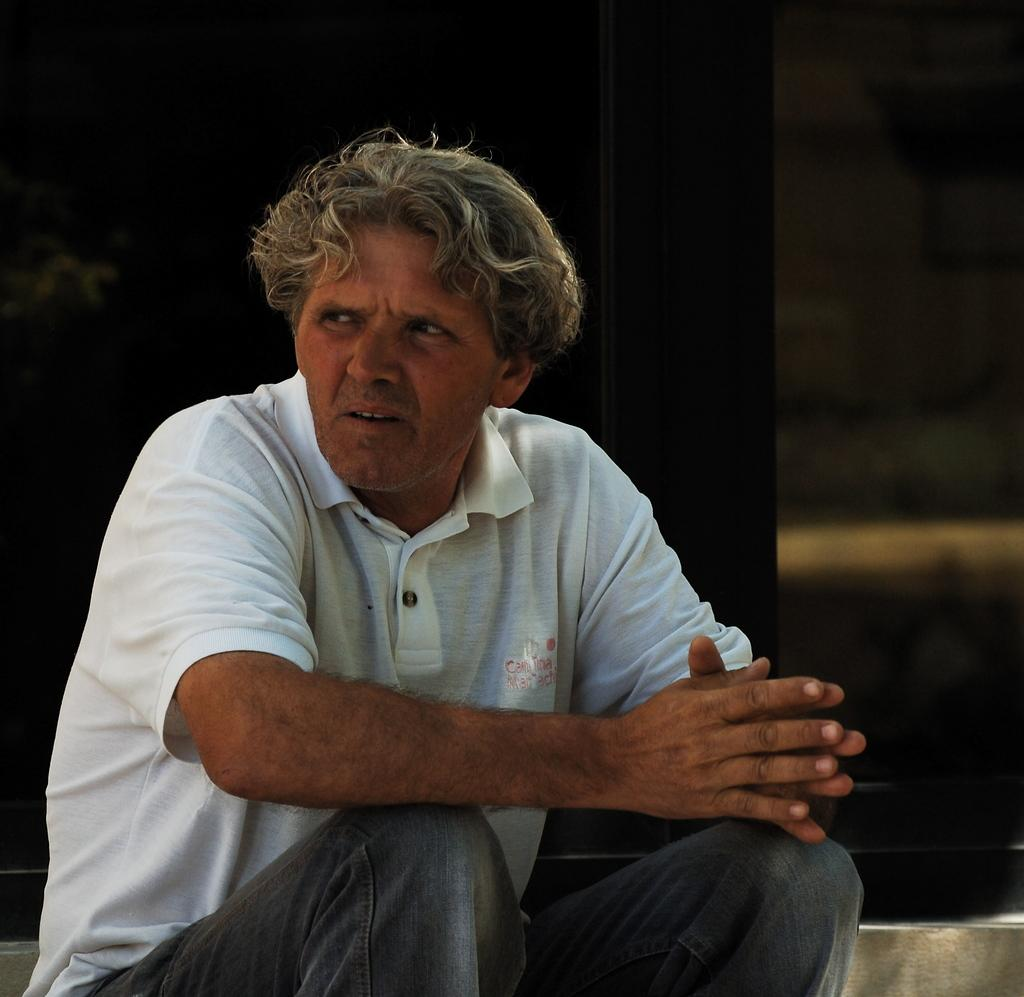What is the man in the image doing? The man is sitting in the image. What is the man wearing? The man is wearing a T-shirt. Can you describe the object behind the man? Unfortunately, the provided facts do not give any information about the object behind the man. How would you describe the overall lighting in the image? The background of the image is dark. What type of territory does the man claim in the image? There is no indication in the image that the man is claiming any territory. What punishment is the man receiving in the image? There is no indication in the image that the man is receiving any punishment. 